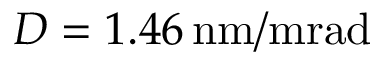<formula> <loc_0><loc_0><loc_500><loc_500>D = 1 . 4 6 \, n m / m r a d</formula> 